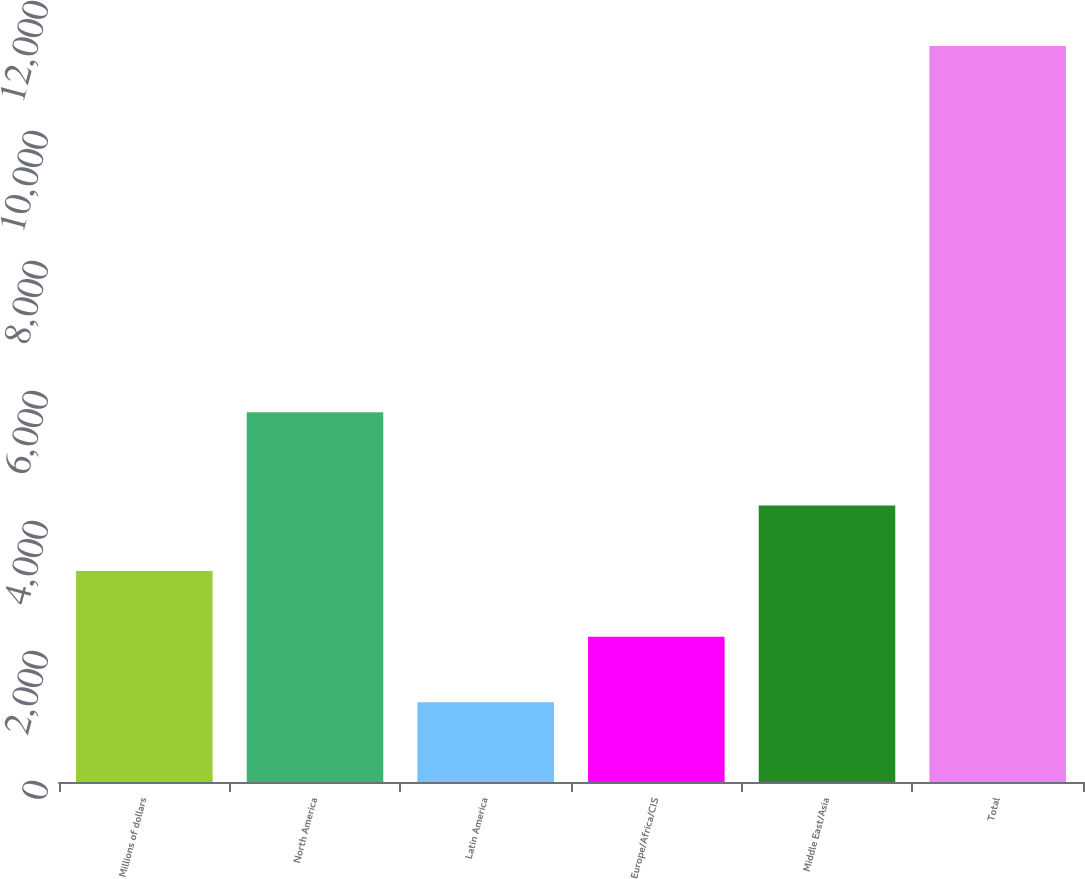<chart> <loc_0><loc_0><loc_500><loc_500><bar_chart><fcel>Millions of dollars<fcel>North America<fcel>Latin America<fcel>Europe/Africa/CIS<fcel>Middle East/Asia<fcel>Total<nl><fcel>3246<fcel>5687<fcel>1227<fcel>2236.5<fcel>4255.5<fcel>11322<nl></chart> 